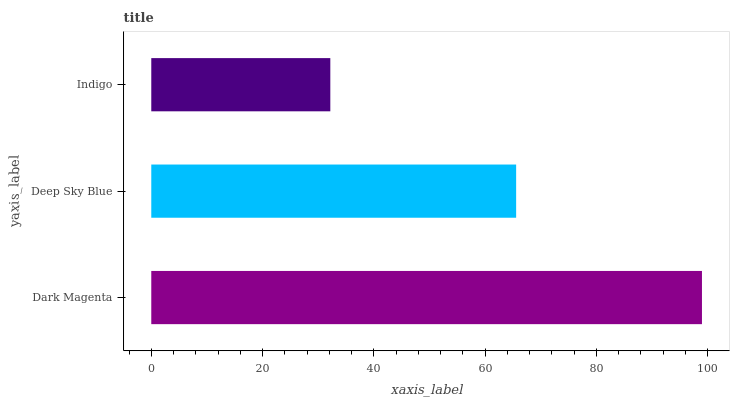Is Indigo the minimum?
Answer yes or no. Yes. Is Dark Magenta the maximum?
Answer yes or no. Yes. Is Deep Sky Blue the minimum?
Answer yes or no. No. Is Deep Sky Blue the maximum?
Answer yes or no. No. Is Dark Magenta greater than Deep Sky Blue?
Answer yes or no. Yes. Is Deep Sky Blue less than Dark Magenta?
Answer yes or no. Yes. Is Deep Sky Blue greater than Dark Magenta?
Answer yes or no. No. Is Dark Magenta less than Deep Sky Blue?
Answer yes or no. No. Is Deep Sky Blue the high median?
Answer yes or no. Yes. Is Deep Sky Blue the low median?
Answer yes or no. Yes. Is Dark Magenta the high median?
Answer yes or no. No. Is Indigo the low median?
Answer yes or no. No. 